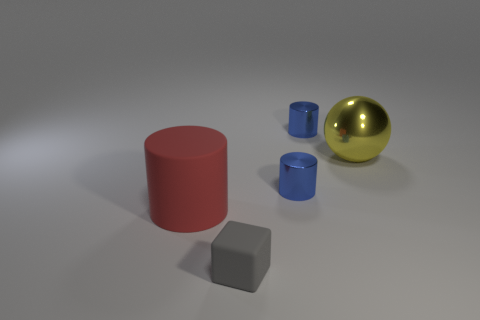Is there any other thing that has the same shape as the gray object?
Keep it short and to the point. No. Is there a large matte cylinder of the same color as the big metal ball?
Keep it short and to the point. No. There is a object that is behind the big sphere; is it the same shape as the big rubber object?
Keep it short and to the point. Yes. What number of red rubber objects are the same size as the yellow metal ball?
Your answer should be very brief. 1. What number of red cylinders are on the right side of the rubber thing that is right of the red cylinder?
Offer a terse response. 0. Are the big object on the right side of the red matte thing and the small gray object made of the same material?
Your answer should be very brief. No. Are the thing in front of the big matte cylinder and the object left of the small gray block made of the same material?
Provide a succinct answer. Yes. Is the number of tiny blue metal objects that are left of the small gray object greater than the number of large yellow objects?
Ensure brevity in your answer.  No. The shiny thing behind the large yellow shiny ball on the right side of the gray block is what color?
Your response must be concise. Blue. What shape is the yellow object that is the same size as the red matte thing?
Your answer should be very brief. Sphere. 